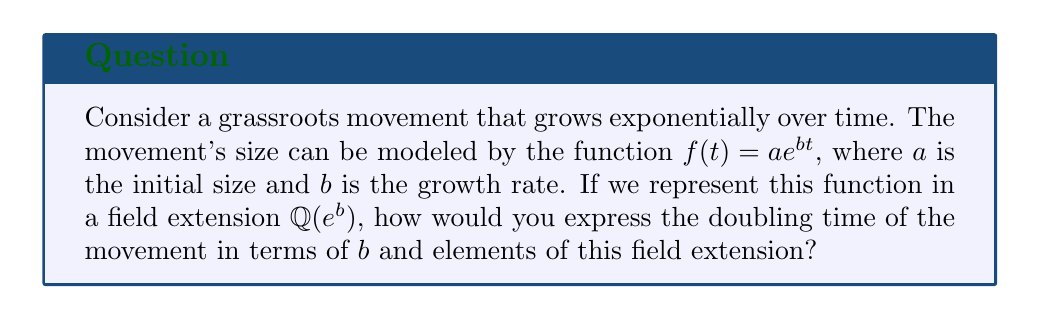What is the answer to this math problem? To solve this problem, we'll follow these steps:

1) The doubling time $t_d$ is the time it takes for the movement to double in size. We can express this mathematically as:

   $$f(t_d) = 2f(0)$$

2) Substituting the given function:

   $$ae^{bt_d} = 2a$$

3) Simplify by canceling $a$ on both sides:

   $$e^{bt_d} = 2$$

4) Take the natural logarithm of both sides:

   $$bt_d = \ln(2)$$

5) Solve for $t_d$:

   $$t_d = \frac{\ln(2)}{b}$$

6) Now, we need to express this in terms of the field extension $\mathbb{Q}(e^b)$. Note that $e^b$ is an element of this field extension.

7) We can rewrite $\ln(2)$ as:

   $$\ln(2) = \frac{\ln((e^b)^{\frac{\ln(2)}{b}})}{b}$$

8) This gives us:

   $$t_d = \frac{\ln((e^b)^{\frac{\ln(2)}{b}})}{b^2}$$

9) In the field extension $\mathbb{Q}(e^b)$, $e^b$ is an algebraic element. Let's call it $\alpha = e^b$. Then our expression becomes:

   $$t_d = \frac{\ln(\alpha^{\frac{\ln(2)}{b}})}{b^2}$$

This expresses the doubling time in terms of $b$ and elements of the field extension $\mathbb{Q}(e^b)$.
Answer: $t_d = \frac{\ln(\alpha^{\frac{\ln(2)}{b}})}{b^2}$, where $\alpha = e^b$ 